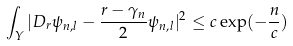<formula> <loc_0><loc_0><loc_500><loc_500>\int _ { Y } | D _ { r } \psi _ { n , l } - \frac { r - \gamma _ { n } } { 2 } \psi _ { n , l } | ^ { 2 } \leq c \exp ( - \frac { n } { c } )</formula> 